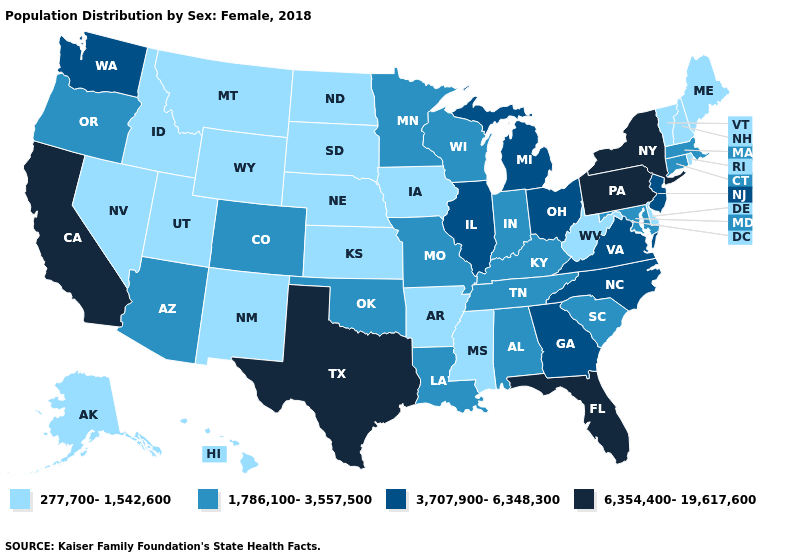What is the highest value in states that border New York?
Short answer required. 6,354,400-19,617,600. Does the first symbol in the legend represent the smallest category?
Give a very brief answer. Yes. Name the states that have a value in the range 3,707,900-6,348,300?
Give a very brief answer. Georgia, Illinois, Michigan, New Jersey, North Carolina, Ohio, Virginia, Washington. Name the states that have a value in the range 6,354,400-19,617,600?
Keep it brief. California, Florida, New York, Pennsylvania, Texas. Among the states that border New Jersey , which have the lowest value?
Write a very short answer. Delaware. Does Michigan have a higher value than Rhode Island?
Quick response, please. Yes. What is the lowest value in states that border Utah?
Be succinct. 277,700-1,542,600. What is the value of Wisconsin?
Answer briefly. 1,786,100-3,557,500. What is the value of South Carolina?
Be succinct. 1,786,100-3,557,500. What is the value of Oklahoma?
Be succinct. 1,786,100-3,557,500. Name the states that have a value in the range 3,707,900-6,348,300?
Short answer required. Georgia, Illinois, Michigan, New Jersey, North Carolina, Ohio, Virginia, Washington. Which states hav the highest value in the South?
Write a very short answer. Florida, Texas. Does Rhode Island have a lower value than Missouri?
Concise answer only. Yes. Does Colorado have the highest value in the West?
Concise answer only. No. Does Virginia have the lowest value in the South?
Concise answer only. No. 